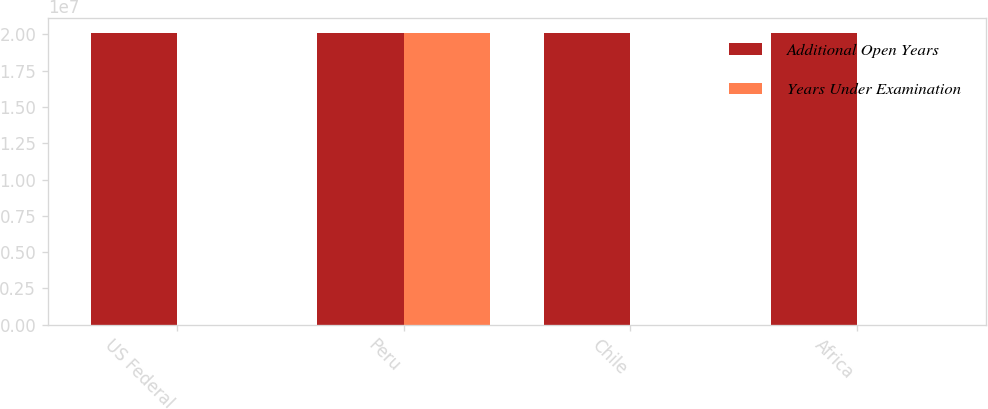Convert chart. <chart><loc_0><loc_0><loc_500><loc_500><stacked_bar_chart><ecel><fcel>US Federal<fcel>Peru<fcel>Chile<fcel>Africa<nl><fcel>Additional Open Years<fcel>2.0072e+07<fcel>2.0092e+07<fcel>2.0112e+07<fcel>2.0102e+07<nl><fcel>Years Under Examination<fcel>2013<fcel>2.0112e+07<fcel>2013<fcel>2013<nl></chart> 